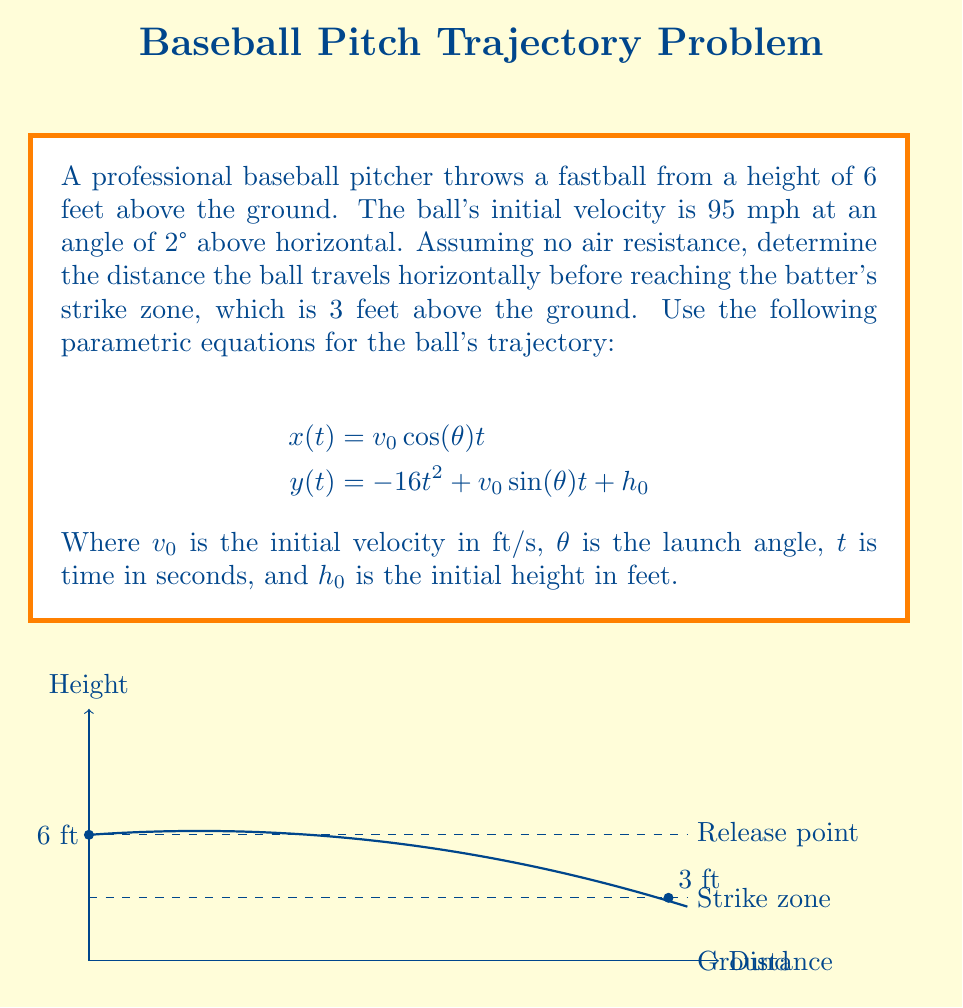Solve this math problem. Let's approach this step-by-step:

1) First, convert the initial velocity from mph to ft/s:
   $v_0 = 95 \text{ mph} = 95 \times \frac{5280}{3600} = 139.33 \text{ ft/s}$

2) We're given $\theta = 2°$ and $h_0 = 6 \text{ ft}$

3) We need to find $t$ when $y(t) = 3$ (the height of the strike zone). Substitute into the y-equation:

   $3 = -16t^2 + 139.33 \sin(2°) t + 6$

4) Simplify:
   $-3 = -16t^2 + 4.86t$

5) Rearrange to standard quadratic form:
   $16t^2 - 4.86t - 3 = 0$

6) Solve using the quadratic formula $t = \frac{-b \pm \sqrt{b^2 - 4ac}}{2a}$:
   
   $t = \frac{4.86 \pm \sqrt{4.86^2 - 4(16)(-3)}}{2(16)}$

7) This gives us two solutions: $t \approx 0.60 \text{ s}$ or $t \approx 0.31 \text{ s}$

8) The larger $t$ is when the ball is descending, so we use $t \approx 0.60 \text{ s}$

9) Now substitute this $t$ into the x-equation:

   $x(0.60) = 139.33 \cos(2°) (0.60)$

10) Calculate:
    $x \approx 83.51 \text{ ft}$
Answer: $83.51 \text{ ft}$ 